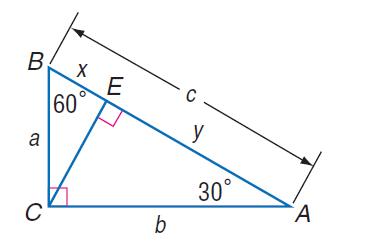Answer the mathemtical geometry problem and directly provide the correct option letter.
Question: If x = 7 \sqrt { 3 }, find a.
Choices: A: 7 B: 12 \sqrt { 3 } C: 14 \sqrt { 3 } D: 16 \sqrt { 3 } C 